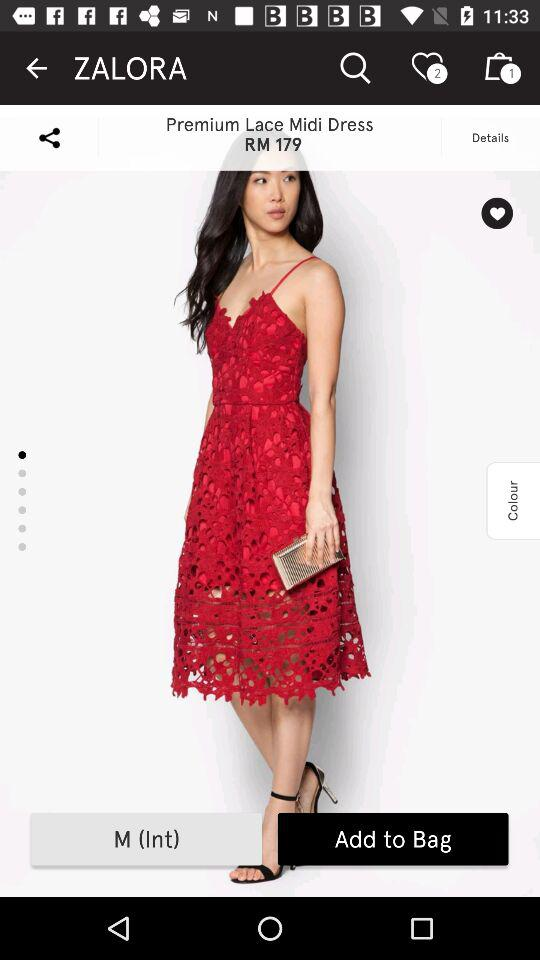What is the application name? The application name is "ZALORA". 